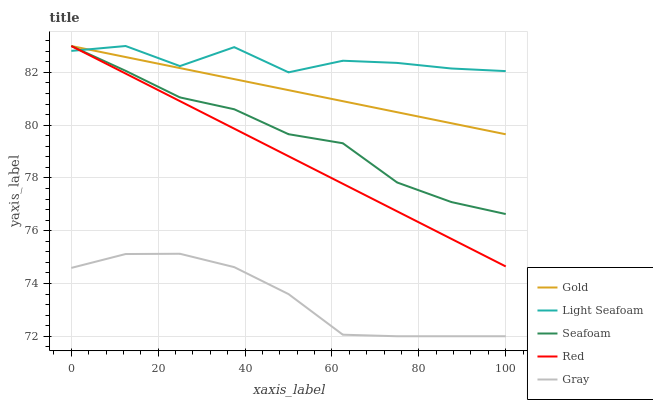Does Gray have the minimum area under the curve?
Answer yes or no. Yes. Does Light Seafoam have the maximum area under the curve?
Answer yes or no. Yes. Does Seafoam have the minimum area under the curve?
Answer yes or no. No. Does Seafoam have the maximum area under the curve?
Answer yes or no. No. Is Red the smoothest?
Answer yes or no. Yes. Is Light Seafoam the roughest?
Answer yes or no. Yes. Is Seafoam the smoothest?
Answer yes or no. No. Is Seafoam the roughest?
Answer yes or no. No. Does Gray have the lowest value?
Answer yes or no. Yes. Does Seafoam have the lowest value?
Answer yes or no. No. Does Gold have the highest value?
Answer yes or no. Yes. Does Gray have the highest value?
Answer yes or no. No. Is Gray less than Gold?
Answer yes or no. Yes. Is Gold greater than Gray?
Answer yes or no. Yes. Does Red intersect Seafoam?
Answer yes or no. Yes. Is Red less than Seafoam?
Answer yes or no. No. Is Red greater than Seafoam?
Answer yes or no. No. Does Gray intersect Gold?
Answer yes or no. No. 